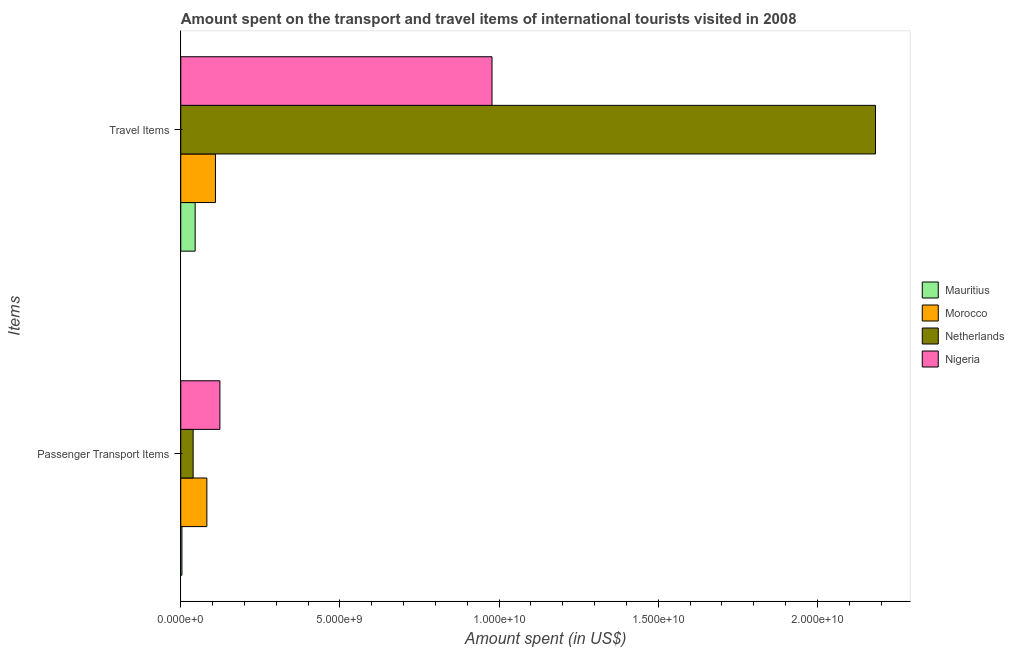Are the number of bars per tick equal to the number of legend labels?
Give a very brief answer. Yes. Are the number of bars on each tick of the Y-axis equal?
Your answer should be compact. Yes. How many bars are there on the 2nd tick from the top?
Give a very brief answer. 4. What is the label of the 2nd group of bars from the top?
Offer a terse response. Passenger Transport Items. What is the amount spent on passenger transport items in Nigeria?
Offer a very short reply. 1.23e+09. Across all countries, what is the maximum amount spent on passenger transport items?
Your response must be concise. 1.23e+09. Across all countries, what is the minimum amount spent in travel items?
Ensure brevity in your answer.  4.52e+08. In which country was the amount spent on passenger transport items minimum?
Ensure brevity in your answer.  Mauritius. What is the total amount spent in travel items in the graph?
Offer a very short reply. 3.31e+1. What is the difference between the amount spent on passenger transport items in Nigeria and that in Mauritius?
Provide a short and direct response. 1.19e+09. What is the difference between the amount spent on passenger transport items in Mauritius and the amount spent in travel items in Netherlands?
Ensure brevity in your answer.  -2.18e+1. What is the average amount spent in travel items per country?
Offer a terse response. 8.29e+09. What is the difference between the amount spent in travel items and amount spent on passenger transport items in Morocco?
Ensure brevity in your answer.  2.70e+08. What is the ratio of the amount spent in travel items in Netherlands to that in Morocco?
Make the answer very short. 20.03. Is the amount spent on passenger transport items in Netherlands less than that in Nigeria?
Give a very brief answer. Yes. In how many countries, is the amount spent in travel items greater than the average amount spent in travel items taken over all countries?
Give a very brief answer. 2. What does the 3rd bar from the top in Passenger Transport Items represents?
Offer a terse response. Morocco. What does the 1st bar from the bottom in Passenger Transport Items represents?
Your answer should be compact. Mauritius. How many countries are there in the graph?
Make the answer very short. 4. What is the difference between two consecutive major ticks on the X-axis?
Ensure brevity in your answer.  5.00e+09. Does the graph contain grids?
Provide a short and direct response. No. How are the legend labels stacked?
Your answer should be compact. Vertical. What is the title of the graph?
Provide a short and direct response. Amount spent on the transport and travel items of international tourists visited in 2008. Does "Angola" appear as one of the legend labels in the graph?
Your answer should be very brief. No. What is the label or title of the X-axis?
Provide a short and direct response. Amount spent (in US$). What is the label or title of the Y-axis?
Your answer should be very brief. Items. What is the Amount spent (in US$) of Mauritius in Passenger Transport Items?
Offer a very short reply. 3.70e+07. What is the Amount spent (in US$) in Morocco in Passenger Transport Items?
Offer a very short reply. 8.20e+08. What is the Amount spent (in US$) in Netherlands in Passenger Transport Items?
Offer a very short reply. 3.89e+08. What is the Amount spent (in US$) of Nigeria in Passenger Transport Items?
Your answer should be very brief. 1.23e+09. What is the Amount spent (in US$) in Mauritius in Travel Items?
Offer a very short reply. 4.52e+08. What is the Amount spent (in US$) in Morocco in Travel Items?
Offer a terse response. 1.09e+09. What is the Amount spent (in US$) in Netherlands in Travel Items?
Your answer should be very brief. 2.18e+1. What is the Amount spent (in US$) of Nigeria in Travel Items?
Your answer should be compact. 9.78e+09. Across all Items, what is the maximum Amount spent (in US$) of Mauritius?
Provide a short and direct response. 4.52e+08. Across all Items, what is the maximum Amount spent (in US$) of Morocco?
Keep it short and to the point. 1.09e+09. Across all Items, what is the maximum Amount spent (in US$) of Netherlands?
Provide a succinct answer. 2.18e+1. Across all Items, what is the maximum Amount spent (in US$) in Nigeria?
Your answer should be very brief. 9.78e+09. Across all Items, what is the minimum Amount spent (in US$) in Mauritius?
Offer a terse response. 3.70e+07. Across all Items, what is the minimum Amount spent (in US$) of Morocco?
Provide a short and direct response. 8.20e+08. Across all Items, what is the minimum Amount spent (in US$) in Netherlands?
Offer a very short reply. 3.89e+08. Across all Items, what is the minimum Amount spent (in US$) of Nigeria?
Offer a terse response. 1.23e+09. What is the total Amount spent (in US$) of Mauritius in the graph?
Provide a succinct answer. 4.89e+08. What is the total Amount spent (in US$) of Morocco in the graph?
Offer a very short reply. 1.91e+09. What is the total Amount spent (in US$) of Netherlands in the graph?
Offer a very short reply. 2.22e+1. What is the total Amount spent (in US$) in Nigeria in the graph?
Your answer should be very brief. 1.10e+1. What is the difference between the Amount spent (in US$) in Mauritius in Passenger Transport Items and that in Travel Items?
Your response must be concise. -4.15e+08. What is the difference between the Amount spent (in US$) of Morocco in Passenger Transport Items and that in Travel Items?
Provide a succinct answer. -2.70e+08. What is the difference between the Amount spent (in US$) of Netherlands in Passenger Transport Items and that in Travel Items?
Your answer should be very brief. -2.14e+1. What is the difference between the Amount spent (in US$) in Nigeria in Passenger Transport Items and that in Travel Items?
Your answer should be very brief. -8.55e+09. What is the difference between the Amount spent (in US$) of Mauritius in Passenger Transport Items and the Amount spent (in US$) of Morocco in Travel Items?
Give a very brief answer. -1.05e+09. What is the difference between the Amount spent (in US$) in Mauritius in Passenger Transport Items and the Amount spent (in US$) in Netherlands in Travel Items?
Offer a terse response. -2.18e+1. What is the difference between the Amount spent (in US$) of Mauritius in Passenger Transport Items and the Amount spent (in US$) of Nigeria in Travel Items?
Your answer should be very brief. -9.74e+09. What is the difference between the Amount spent (in US$) of Morocco in Passenger Transport Items and the Amount spent (in US$) of Netherlands in Travel Items?
Keep it short and to the point. -2.10e+1. What is the difference between the Amount spent (in US$) of Morocco in Passenger Transport Items and the Amount spent (in US$) of Nigeria in Travel Items?
Your response must be concise. -8.96e+09. What is the difference between the Amount spent (in US$) of Netherlands in Passenger Transport Items and the Amount spent (in US$) of Nigeria in Travel Items?
Your response must be concise. -9.39e+09. What is the average Amount spent (in US$) of Mauritius per Items?
Give a very brief answer. 2.44e+08. What is the average Amount spent (in US$) of Morocco per Items?
Ensure brevity in your answer.  9.55e+08. What is the average Amount spent (in US$) of Netherlands per Items?
Provide a short and direct response. 1.11e+1. What is the average Amount spent (in US$) in Nigeria per Items?
Provide a succinct answer. 5.50e+09. What is the difference between the Amount spent (in US$) in Mauritius and Amount spent (in US$) in Morocco in Passenger Transport Items?
Your answer should be compact. -7.83e+08. What is the difference between the Amount spent (in US$) in Mauritius and Amount spent (in US$) in Netherlands in Passenger Transport Items?
Your answer should be compact. -3.52e+08. What is the difference between the Amount spent (in US$) of Mauritius and Amount spent (in US$) of Nigeria in Passenger Transport Items?
Offer a terse response. -1.19e+09. What is the difference between the Amount spent (in US$) of Morocco and Amount spent (in US$) of Netherlands in Passenger Transport Items?
Offer a very short reply. 4.31e+08. What is the difference between the Amount spent (in US$) of Morocco and Amount spent (in US$) of Nigeria in Passenger Transport Items?
Your response must be concise. -4.10e+08. What is the difference between the Amount spent (in US$) of Netherlands and Amount spent (in US$) of Nigeria in Passenger Transport Items?
Ensure brevity in your answer.  -8.41e+08. What is the difference between the Amount spent (in US$) in Mauritius and Amount spent (in US$) in Morocco in Travel Items?
Your response must be concise. -6.38e+08. What is the difference between the Amount spent (in US$) in Mauritius and Amount spent (in US$) in Netherlands in Travel Items?
Make the answer very short. -2.14e+1. What is the difference between the Amount spent (in US$) of Mauritius and Amount spent (in US$) of Nigeria in Travel Items?
Offer a terse response. -9.33e+09. What is the difference between the Amount spent (in US$) of Morocco and Amount spent (in US$) of Netherlands in Travel Items?
Offer a very short reply. -2.07e+1. What is the difference between the Amount spent (in US$) of Morocco and Amount spent (in US$) of Nigeria in Travel Items?
Offer a very short reply. -8.69e+09. What is the difference between the Amount spent (in US$) of Netherlands and Amount spent (in US$) of Nigeria in Travel Items?
Offer a very short reply. 1.20e+1. What is the ratio of the Amount spent (in US$) in Mauritius in Passenger Transport Items to that in Travel Items?
Provide a succinct answer. 0.08. What is the ratio of the Amount spent (in US$) of Morocco in Passenger Transport Items to that in Travel Items?
Keep it short and to the point. 0.75. What is the ratio of the Amount spent (in US$) in Netherlands in Passenger Transport Items to that in Travel Items?
Your answer should be compact. 0.02. What is the ratio of the Amount spent (in US$) in Nigeria in Passenger Transport Items to that in Travel Items?
Provide a short and direct response. 0.13. What is the difference between the highest and the second highest Amount spent (in US$) of Mauritius?
Give a very brief answer. 4.15e+08. What is the difference between the highest and the second highest Amount spent (in US$) of Morocco?
Your answer should be compact. 2.70e+08. What is the difference between the highest and the second highest Amount spent (in US$) of Netherlands?
Offer a very short reply. 2.14e+1. What is the difference between the highest and the second highest Amount spent (in US$) in Nigeria?
Your response must be concise. 8.55e+09. What is the difference between the highest and the lowest Amount spent (in US$) of Mauritius?
Provide a short and direct response. 4.15e+08. What is the difference between the highest and the lowest Amount spent (in US$) of Morocco?
Keep it short and to the point. 2.70e+08. What is the difference between the highest and the lowest Amount spent (in US$) in Netherlands?
Ensure brevity in your answer.  2.14e+1. What is the difference between the highest and the lowest Amount spent (in US$) in Nigeria?
Ensure brevity in your answer.  8.55e+09. 